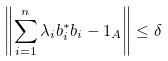<formula> <loc_0><loc_0><loc_500><loc_500>\left \| \sum _ { i = 1 } ^ { n } \lambda _ { i } b _ { i } ^ { * } b _ { i } - 1 _ { A } \right \| \leq \delta</formula> 